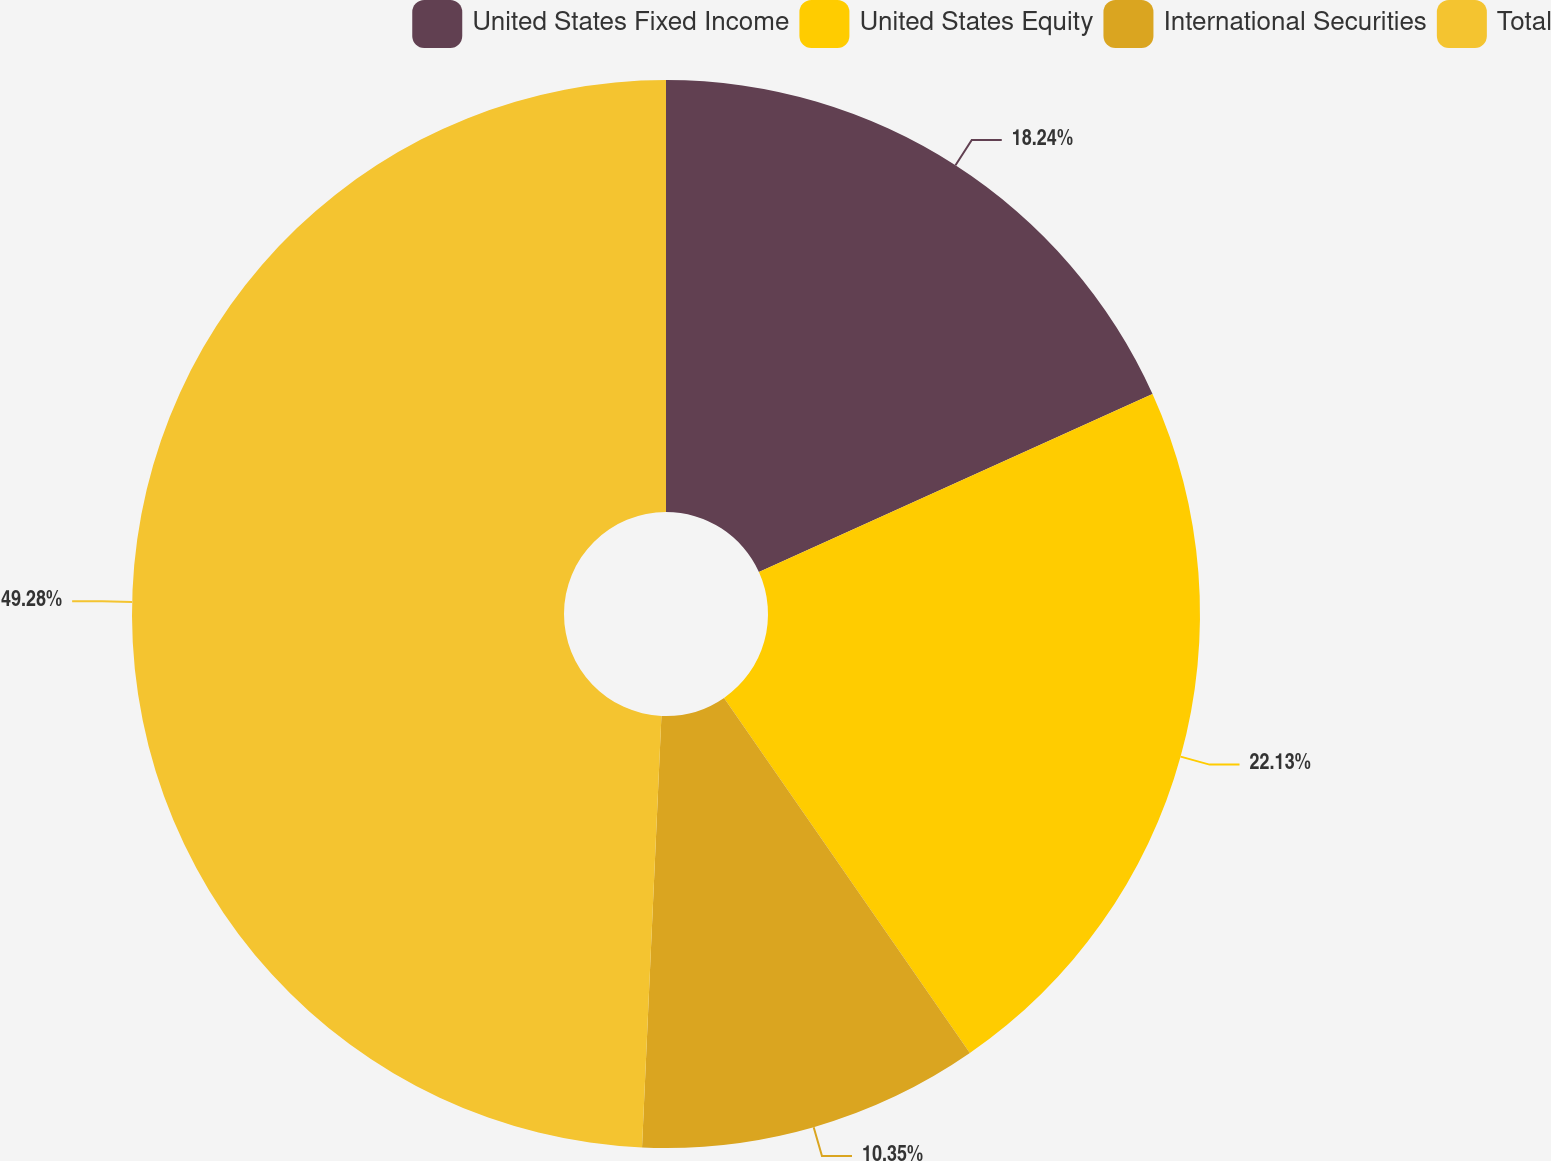Convert chart. <chart><loc_0><loc_0><loc_500><loc_500><pie_chart><fcel>United States Fixed Income<fcel>United States Equity<fcel>International Securities<fcel>Total<nl><fcel>18.24%<fcel>22.13%<fcel>10.35%<fcel>49.29%<nl></chart> 